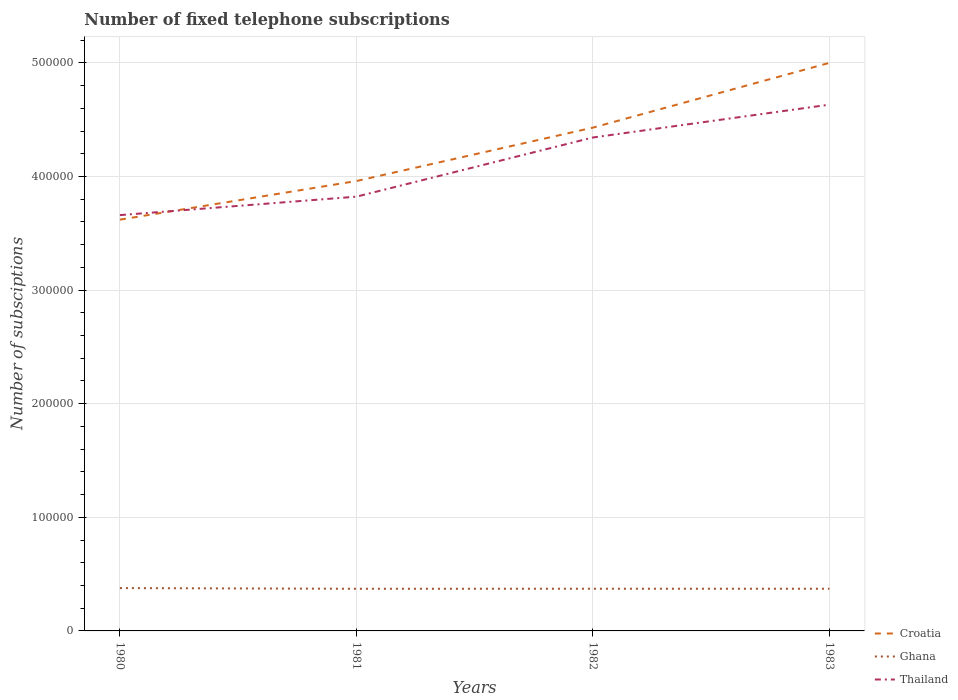How many different coloured lines are there?
Ensure brevity in your answer.  3. Across all years, what is the maximum number of fixed telephone subscriptions in Ghana?
Provide a succinct answer. 3.71e+04. What is the total number of fixed telephone subscriptions in Ghana in the graph?
Make the answer very short. 543. What is the difference between the highest and the second highest number of fixed telephone subscriptions in Thailand?
Give a very brief answer. 9.72e+04. What is the difference between the highest and the lowest number of fixed telephone subscriptions in Ghana?
Your answer should be very brief. 1. How many lines are there?
Your answer should be compact. 3. How many years are there in the graph?
Your response must be concise. 4. Are the values on the major ticks of Y-axis written in scientific E-notation?
Offer a terse response. No. Does the graph contain any zero values?
Make the answer very short. No. Does the graph contain grids?
Provide a short and direct response. Yes. Where does the legend appear in the graph?
Give a very brief answer. Bottom right. How are the legend labels stacked?
Your response must be concise. Vertical. What is the title of the graph?
Make the answer very short. Number of fixed telephone subscriptions. Does "Turkey" appear as one of the legend labels in the graph?
Keep it short and to the point. No. What is the label or title of the Y-axis?
Provide a succinct answer. Number of subsciptions. What is the Number of subsciptions in Croatia in 1980?
Offer a terse response. 3.62e+05. What is the Number of subsciptions in Ghana in 1980?
Provide a succinct answer. 3.77e+04. What is the Number of subsciptions of Thailand in 1980?
Provide a short and direct response. 3.66e+05. What is the Number of subsciptions of Croatia in 1981?
Ensure brevity in your answer.  3.96e+05. What is the Number of subsciptions of Ghana in 1981?
Offer a very short reply. 3.71e+04. What is the Number of subsciptions of Thailand in 1981?
Provide a short and direct response. 3.82e+05. What is the Number of subsciptions in Croatia in 1982?
Ensure brevity in your answer.  4.43e+05. What is the Number of subsciptions of Ghana in 1982?
Your answer should be compact. 3.72e+04. What is the Number of subsciptions of Thailand in 1982?
Offer a very short reply. 4.34e+05. What is the Number of subsciptions in Ghana in 1983?
Make the answer very short. 3.71e+04. What is the Number of subsciptions in Thailand in 1983?
Provide a short and direct response. 4.63e+05. Across all years, what is the maximum Number of subsciptions in Croatia?
Provide a short and direct response. 5.00e+05. Across all years, what is the maximum Number of subsciptions of Ghana?
Give a very brief answer. 3.77e+04. Across all years, what is the maximum Number of subsciptions in Thailand?
Offer a terse response. 4.63e+05. Across all years, what is the minimum Number of subsciptions of Croatia?
Your response must be concise. 3.62e+05. Across all years, what is the minimum Number of subsciptions in Ghana?
Provide a short and direct response. 3.71e+04. Across all years, what is the minimum Number of subsciptions of Thailand?
Provide a succinct answer. 3.66e+05. What is the total Number of subsciptions in Croatia in the graph?
Offer a terse response. 1.70e+06. What is the total Number of subsciptions in Ghana in the graph?
Your answer should be compact. 1.49e+05. What is the total Number of subsciptions in Thailand in the graph?
Provide a succinct answer. 1.65e+06. What is the difference between the Number of subsciptions of Croatia in 1980 and that in 1981?
Your answer should be compact. -3.40e+04. What is the difference between the Number of subsciptions of Ghana in 1980 and that in 1981?
Keep it short and to the point. 591. What is the difference between the Number of subsciptions of Thailand in 1980 and that in 1981?
Offer a very short reply. -1.62e+04. What is the difference between the Number of subsciptions of Croatia in 1980 and that in 1982?
Give a very brief answer. -8.10e+04. What is the difference between the Number of subsciptions of Ghana in 1980 and that in 1982?
Your answer should be very brief. 543. What is the difference between the Number of subsciptions in Thailand in 1980 and that in 1982?
Offer a very short reply. -6.83e+04. What is the difference between the Number of subsciptions in Croatia in 1980 and that in 1983?
Ensure brevity in your answer.  -1.38e+05. What is the difference between the Number of subsciptions of Ghana in 1980 and that in 1983?
Your answer should be very brief. 565. What is the difference between the Number of subsciptions of Thailand in 1980 and that in 1983?
Offer a terse response. -9.72e+04. What is the difference between the Number of subsciptions in Croatia in 1981 and that in 1982?
Ensure brevity in your answer.  -4.70e+04. What is the difference between the Number of subsciptions of Ghana in 1981 and that in 1982?
Your answer should be compact. -48. What is the difference between the Number of subsciptions in Thailand in 1981 and that in 1982?
Make the answer very short. -5.21e+04. What is the difference between the Number of subsciptions of Croatia in 1981 and that in 1983?
Your answer should be very brief. -1.04e+05. What is the difference between the Number of subsciptions of Ghana in 1981 and that in 1983?
Offer a terse response. -26. What is the difference between the Number of subsciptions in Thailand in 1981 and that in 1983?
Offer a very short reply. -8.10e+04. What is the difference between the Number of subsciptions of Croatia in 1982 and that in 1983?
Your response must be concise. -5.70e+04. What is the difference between the Number of subsciptions in Ghana in 1982 and that in 1983?
Provide a succinct answer. 22. What is the difference between the Number of subsciptions in Thailand in 1982 and that in 1983?
Give a very brief answer. -2.89e+04. What is the difference between the Number of subsciptions of Croatia in 1980 and the Number of subsciptions of Ghana in 1981?
Provide a short and direct response. 3.25e+05. What is the difference between the Number of subsciptions of Croatia in 1980 and the Number of subsciptions of Thailand in 1981?
Offer a very short reply. -2.02e+04. What is the difference between the Number of subsciptions in Ghana in 1980 and the Number of subsciptions in Thailand in 1981?
Ensure brevity in your answer.  -3.45e+05. What is the difference between the Number of subsciptions in Croatia in 1980 and the Number of subsciptions in Ghana in 1982?
Provide a short and direct response. 3.25e+05. What is the difference between the Number of subsciptions in Croatia in 1980 and the Number of subsciptions in Thailand in 1982?
Make the answer very short. -7.23e+04. What is the difference between the Number of subsciptions in Ghana in 1980 and the Number of subsciptions in Thailand in 1982?
Offer a terse response. -3.97e+05. What is the difference between the Number of subsciptions of Croatia in 1980 and the Number of subsciptions of Ghana in 1983?
Give a very brief answer. 3.25e+05. What is the difference between the Number of subsciptions of Croatia in 1980 and the Number of subsciptions of Thailand in 1983?
Offer a very short reply. -1.01e+05. What is the difference between the Number of subsciptions of Ghana in 1980 and the Number of subsciptions of Thailand in 1983?
Make the answer very short. -4.26e+05. What is the difference between the Number of subsciptions in Croatia in 1981 and the Number of subsciptions in Ghana in 1982?
Provide a succinct answer. 3.59e+05. What is the difference between the Number of subsciptions of Croatia in 1981 and the Number of subsciptions of Thailand in 1982?
Provide a short and direct response. -3.83e+04. What is the difference between the Number of subsciptions of Ghana in 1981 and the Number of subsciptions of Thailand in 1982?
Keep it short and to the point. -3.97e+05. What is the difference between the Number of subsciptions of Croatia in 1981 and the Number of subsciptions of Ghana in 1983?
Your answer should be compact. 3.59e+05. What is the difference between the Number of subsciptions of Croatia in 1981 and the Number of subsciptions of Thailand in 1983?
Your answer should be very brief. -6.72e+04. What is the difference between the Number of subsciptions in Ghana in 1981 and the Number of subsciptions in Thailand in 1983?
Ensure brevity in your answer.  -4.26e+05. What is the difference between the Number of subsciptions of Croatia in 1982 and the Number of subsciptions of Ghana in 1983?
Offer a terse response. 4.06e+05. What is the difference between the Number of subsciptions in Croatia in 1982 and the Number of subsciptions in Thailand in 1983?
Your response must be concise. -2.02e+04. What is the difference between the Number of subsciptions of Ghana in 1982 and the Number of subsciptions of Thailand in 1983?
Offer a terse response. -4.26e+05. What is the average Number of subsciptions in Croatia per year?
Your answer should be very brief. 4.25e+05. What is the average Number of subsciptions in Ghana per year?
Keep it short and to the point. 3.73e+04. What is the average Number of subsciptions in Thailand per year?
Your answer should be compact. 4.11e+05. In the year 1980, what is the difference between the Number of subsciptions of Croatia and Number of subsciptions of Ghana?
Ensure brevity in your answer.  3.24e+05. In the year 1980, what is the difference between the Number of subsciptions in Croatia and Number of subsciptions in Thailand?
Your answer should be very brief. -4000. In the year 1980, what is the difference between the Number of subsciptions of Ghana and Number of subsciptions of Thailand?
Provide a short and direct response. -3.28e+05. In the year 1981, what is the difference between the Number of subsciptions of Croatia and Number of subsciptions of Ghana?
Offer a very short reply. 3.59e+05. In the year 1981, what is the difference between the Number of subsciptions in Croatia and Number of subsciptions in Thailand?
Give a very brief answer. 1.38e+04. In the year 1981, what is the difference between the Number of subsciptions in Ghana and Number of subsciptions in Thailand?
Provide a short and direct response. -3.45e+05. In the year 1982, what is the difference between the Number of subsciptions of Croatia and Number of subsciptions of Ghana?
Make the answer very short. 4.06e+05. In the year 1982, what is the difference between the Number of subsciptions in Croatia and Number of subsciptions in Thailand?
Ensure brevity in your answer.  8680. In the year 1982, what is the difference between the Number of subsciptions of Ghana and Number of subsciptions of Thailand?
Offer a very short reply. -3.97e+05. In the year 1983, what is the difference between the Number of subsciptions in Croatia and Number of subsciptions in Ghana?
Your response must be concise. 4.63e+05. In the year 1983, what is the difference between the Number of subsciptions in Croatia and Number of subsciptions in Thailand?
Ensure brevity in your answer.  3.68e+04. In the year 1983, what is the difference between the Number of subsciptions of Ghana and Number of subsciptions of Thailand?
Make the answer very short. -4.26e+05. What is the ratio of the Number of subsciptions of Croatia in 1980 to that in 1981?
Keep it short and to the point. 0.91. What is the ratio of the Number of subsciptions of Ghana in 1980 to that in 1981?
Provide a succinct answer. 1.02. What is the ratio of the Number of subsciptions of Thailand in 1980 to that in 1981?
Ensure brevity in your answer.  0.96. What is the ratio of the Number of subsciptions of Croatia in 1980 to that in 1982?
Make the answer very short. 0.82. What is the ratio of the Number of subsciptions in Ghana in 1980 to that in 1982?
Ensure brevity in your answer.  1.01. What is the ratio of the Number of subsciptions in Thailand in 1980 to that in 1982?
Make the answer very short. 0.84. What is the ratio of the Number of subsciptions of Croatia in 1980 to that in 1983?
Your answer should be very brief. 0.72. What is the ratio of the Number of subsciptions in Ghana in 1980 to that in 1983?
Your answer should be very brief. 1.02. What is the ratio of the Number of subsciptions of Thailand in 1980 to that in 1983?
Your response must be concise. 0.79. What is the ratio of the Number of subsciptions in Croatia in 1981 to that in 1982?
Keep it short and to the point. 0.89. What is the ratio of the Number of subsciptions in Thailand in 1981 to that in 1982?
Offer a terse response. 0.88. What is the ratio of the Number of subsciptions of Croatia in 1981 to that in 1983?
Provide a short and direct response. 0.79. What is the ratio of the Number of subsciptions of Thailand in 1981 to that in 1983?
Your answer should be compact. 0.83. What is the ratio of the Number of subsciptions in Croatia in 1982 to that in 1983?
Provide a succinct answer. 0.89. What is the ratio of the Number of subsciptions of Ghana in 1982 to that in 1983?
Make the answer very short. 1. What is the ratio of the Number of subsciptions of Thailand in 1982 to that in 1983?
Your answer should be compact. 0.94. What is the difference between the highest and the second highest Number of subsciptions in Croatia?
Provide a short and direct response. 5.70e+04. What is the difference between the highest and the second highest Number of subsciptions in Ghana?
Your answer should be compact. 543. What is the difference between the highest and the second highest Number of subsciptions of Thailand?
Keep it short and to the point. 2.89e+04. What is the difference between the highest and the lowest Number of subsciptions in Croatia?
Offer a very short reply. 1.38e+05. What is the difference between the highest and the lowest Number of subsciptions in Ghana?
Your answer should be compact. 591. What is the difference between the highest and the lowest Number of subsciptions in Thailand?
Provide a succinct answer. 9.72e+04. 